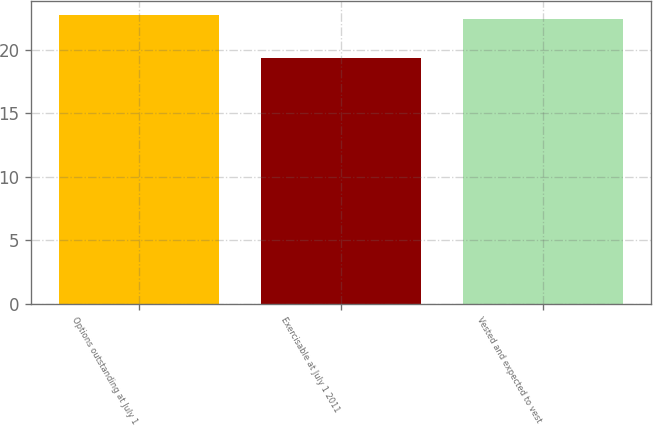Convert chart to OTSL. <chart><loc_0><loc_0><loc_500><loc_500><bar_chart><fcel>Options outstanding at July 1<fcel>Exercisable at July 1 2011<fcel>Vested and expected to vest<nl><fcel>22.74<fcel>19.36<fcel>22.43<nl></chart> 